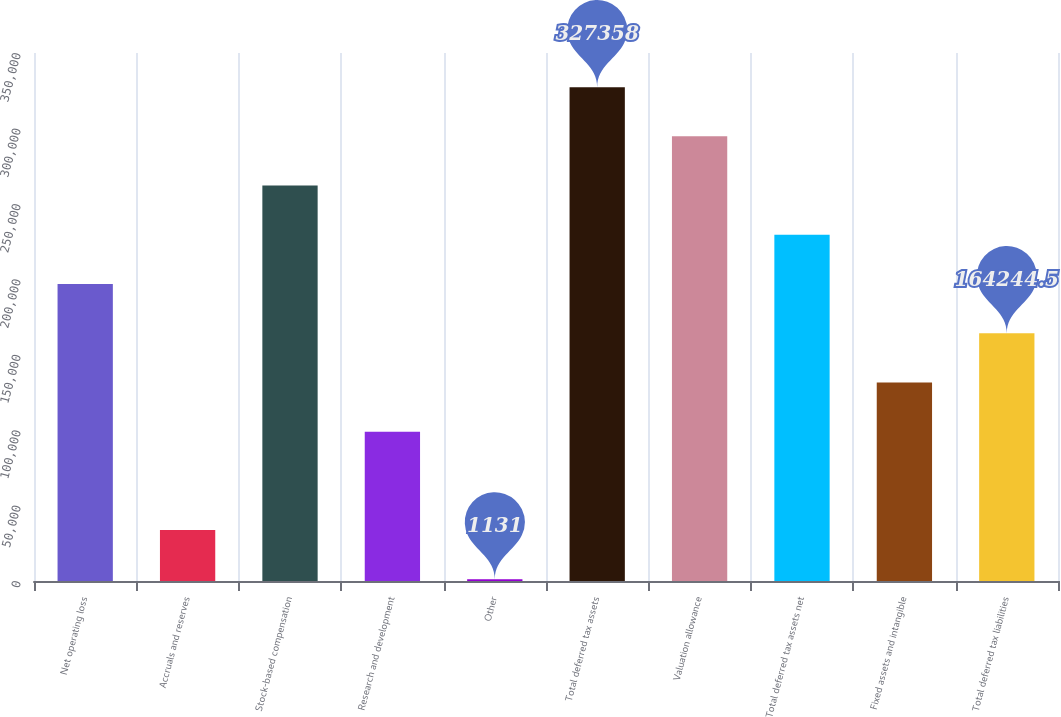<chart> <loc_0><loc_0><loc_500><loc_500><bar_chart><fcel>Net operating loss<fcel>Accruals and reserves<fcel>Stock-based compensation<fcel>Research and development<fcel>Other<fcel>Total deferred tax assets<fcel>Valuation allowance<fcel>Total deferred tax assets net<fcel>Fixed assets and intangible<fcel>Total deferred tax liabilities<nl><fcel>196867<fcel>33753.7<fcel>262113<fcel>98999.1<fcel>1131<fcel>327358<fcel>294735<fcel>229490<fcel>131622<fcel>164244<nl></chart> 